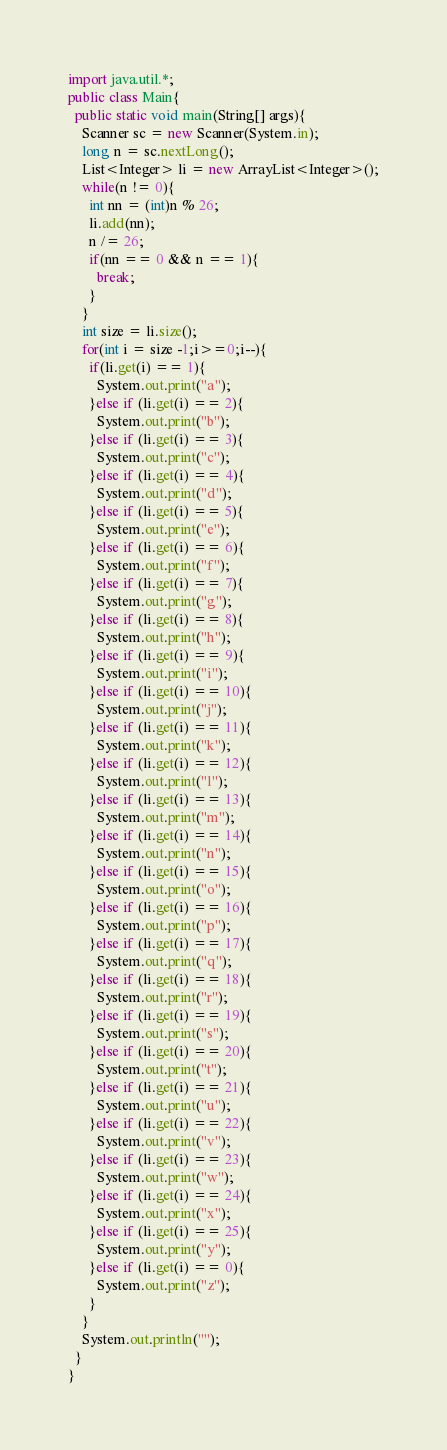Convert code to text. <code><loc_0><loc_0><loc_500><loc_500><_Java_>import java.util.*;
public class Main{
  public static void main(String[] args){
    Scanner sc = new Scanner(System.in);
    long n = sc.nextLong();
    List<Integer> li = new ArrayList<Integer>();
    while(n != 0){
      int nn = (int)n % 26;
      li.add(nn);
      n /= 26;
      if(nn == 0 && n == 1){
        break;
      }
    }
    int size = li.size();
    for(int i = size -1;i>=0;i--){
      if(li.get(i) == 1){
        System.out.print("a");
      }else if (li.get(i) == 2){
        System.out.print("b");
      }else if (li.get(i) == 3){
        System.out.print("c");
      }else if (li.get(i) == 4){
        System.out.print("d");
      }else if (li.get(i) == 5){
        System.out.print("e");
      }else if (li.get(i) == 6){
        System.out.print("f");
      }else if (li.get(i) == 7){
        System.out.print("g");
      }else if (li.get(i) == 8){
        System.out.print("h");
      }else if (li.get(i) == 9){
        System.out.print("i");
      }else if (li.get(i) == 10){
        System.out.print("j");
      }else if (li.get(i) == 11){
        System.out.print("k");
      }else if (li.get(i) == 12){
        System.out.print("l");
      }else if (li.get(i) == 13){
        System.out.print("m");
      }else if (li.get(i) == 14){
        System.out.print("n");
      }else if (li.get(i) == 15){
        System.out.print("o");
      }else if (li.get(i) == 16){
        System.out.print("p");
      }else if (li.get(i) == 17){
        System.out.print("q");
      }else if (li.get(i) == 18){
        System.out.print("r");
      }else if (li.get(i) == 19){
        System.out.print("s");
      }else if (li.get(i) == 20){
        System.out.print("t");
      }else if (li.get(i) == 21){
        System.out.print("u");
      }else if (li.get(i) == 22){
        System.out.print("v");
      }else if (li.get(i) == 23){
        System.out.print("w");
      }else if (li.get(i) == 24){
        System.out.print("x");
      }else if (li.get(i) == 25){
        System.out.print("y");
      }else if (li.get(i) == 0){
        System.out.print("z");
      }
    }
    System.out.println("");
  }
}
</code> 